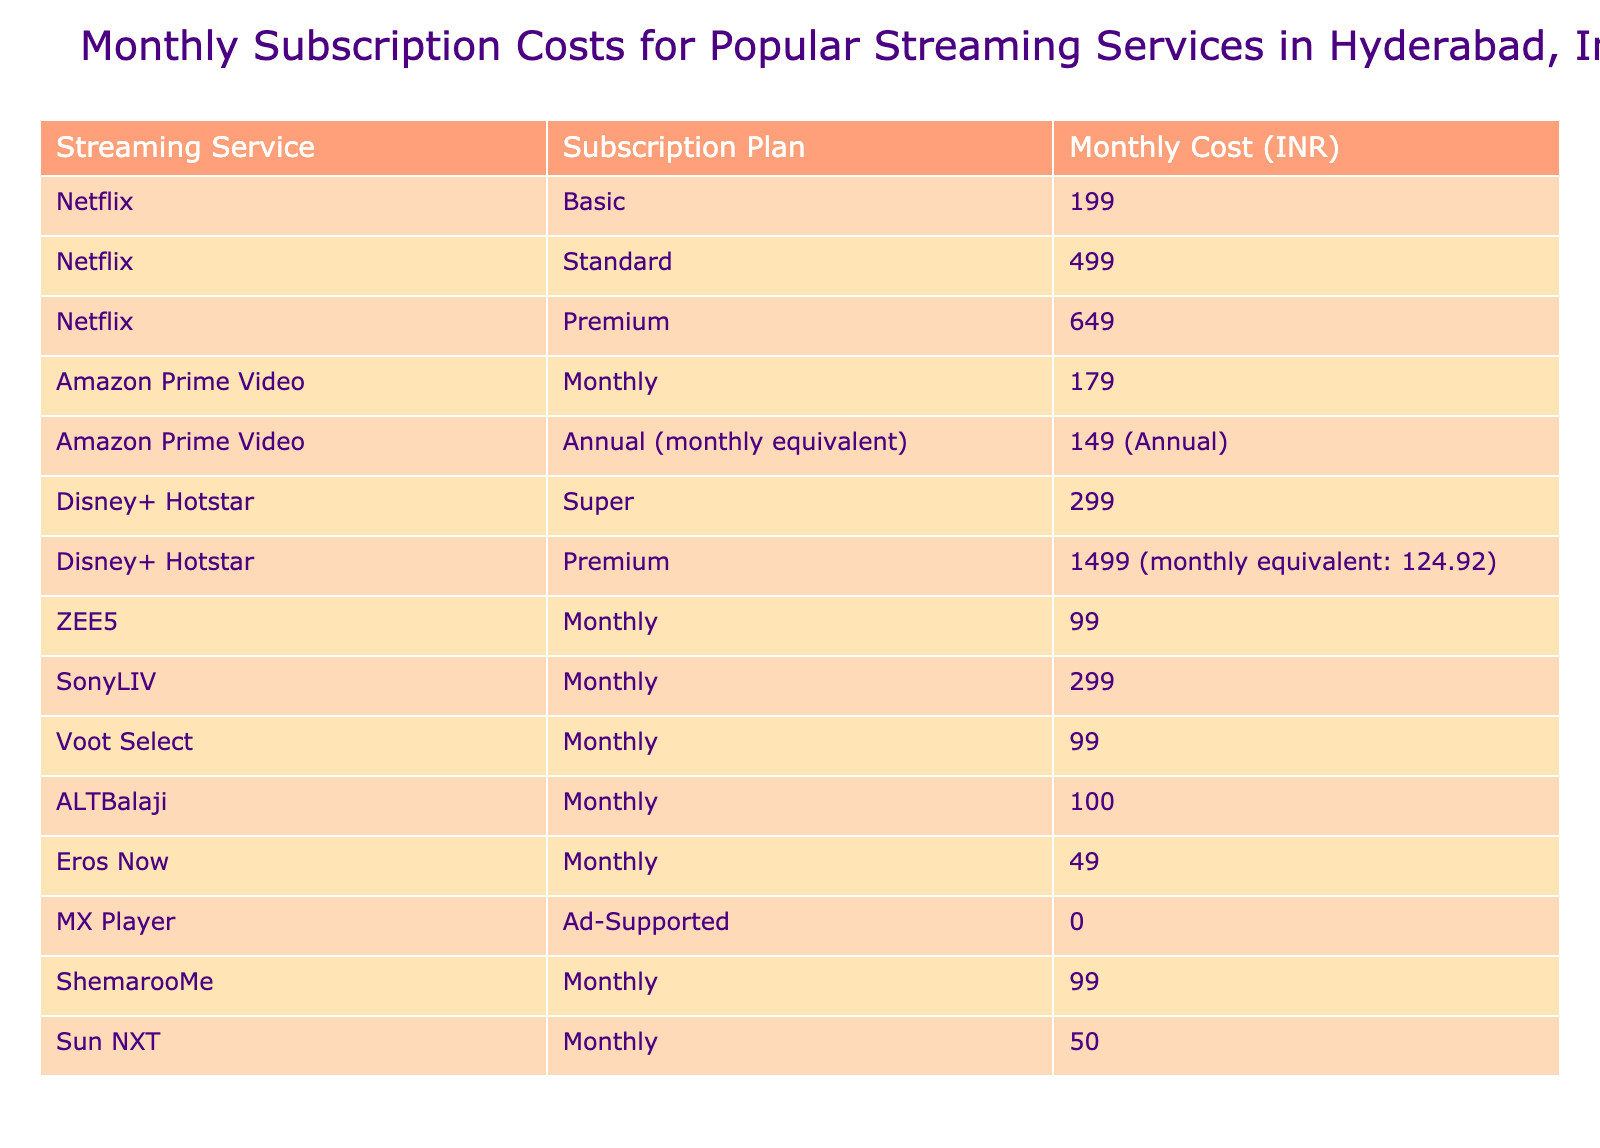What is the monthly cost of Netflix's Premium subscription plan? The table lists the subscription plans and their respective monthly costs. Under Netflix, the Premium plan is priced at 649 INR.
Answer: 649 Which streaming service has the lowest monthly subscription cost? By examining the table, we see that Eros Now has a monthly cost of 49 INR, which is the lowest among all listed services.
Answer: Eros Now (49 INR) What is the total monthly cost of all subscription plans for Amazon Prime Video? The table shows two plans for Amazon Prime Video: Monthly at 179 INR and Annual (monthly equivalent) at 149 INR. Adding these: 179 + 149 = 328 INR.
Answer: 328 How much more is the Netflix Premium plan compared to the ZEE5 Monthly plan? The Netflix Premium plan costs 649 INR and ZEE5 Monthly plan costs 99 INR. The difference is calculated as 649 - 99 = 550 INR.
Answer: 550 Is the monthly subscription cost for Sun NXT greater than that of Disney+ Hotstar’s Premium plan? The cost for Sun NXT is 50 INR, while the Disney+ Hotstar Premium plan is 1499 INR. Since 50 is less than 1499, the statement is false.
Answer: No Which service offers a monthly subscription plan at 99 INR? Looking at the table, both ZEE5 and Voot Select list a Monthly cost of 99 INR. Thus, they are the services offering this price point.
Answer: ZEE5 and Voot Select If a person subscribes to both Amazon Prime Video's Monthly plan and ZEE5, what would their total monthly cost be? The costs are 179 INR for Amazon Prime Video's Monthly plan and 99 INR for ZEE5. Adding these gives us 179 + 99 = 278 INR.
Answer: 278 What is the average monthly cost of all Netflix plans? The monthly costs for Netflix plans are 199, 499, and 649 INR. To find the average, we sum the values: 199 + 499 + 649 = 1347, then divide by 3 (the number of plans): 1347 / 3 = 449 INR.
Answer: 449 